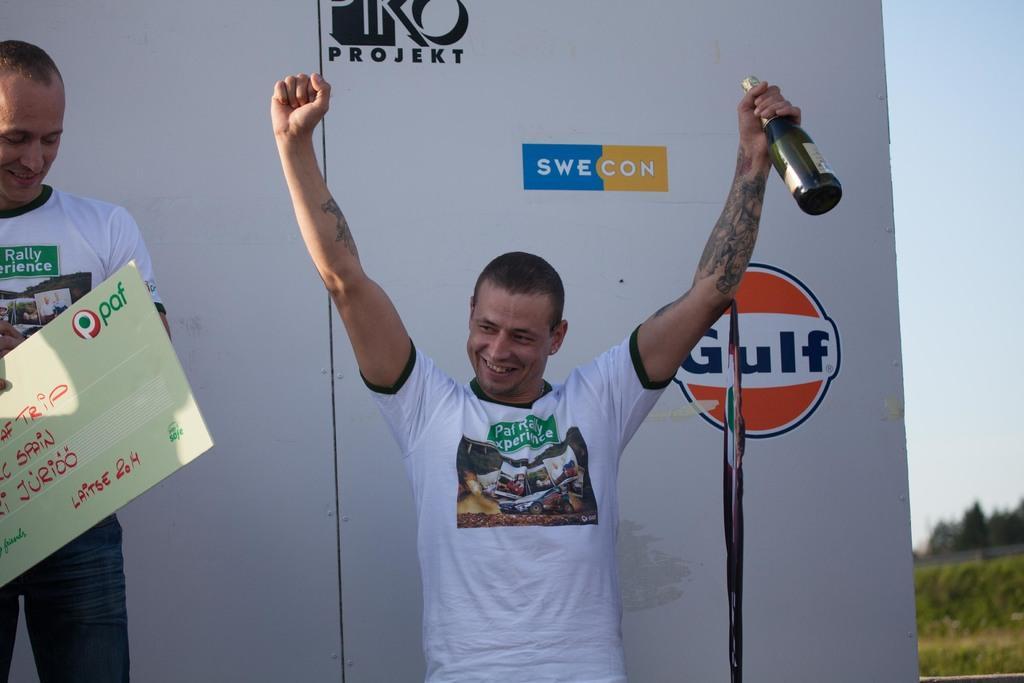Could you give a brief overview of what you see in this image? To the left side there is a man with white t-shirt is standing and and holding a voucher in his hand and he is smiling. Beside him there is another man standing and holding a bottle in his hand. And he is smiling. Behind them there is a poster and logos on it. 